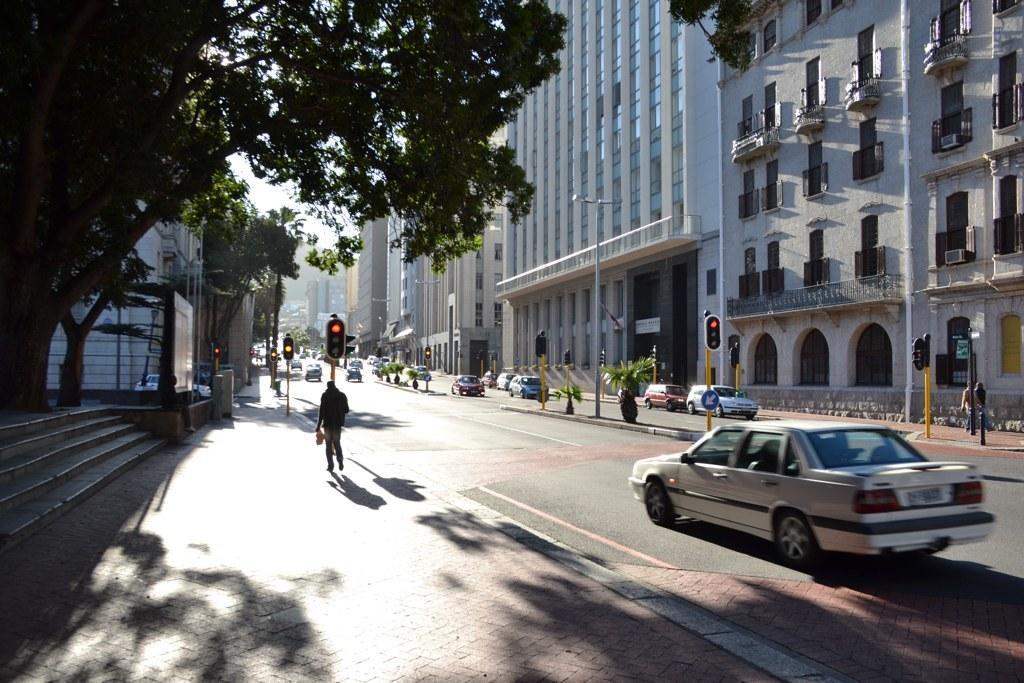Describe this image in one or two sentences. In this image I can see the road, few vehicles on the road, the sidewalk, few persons standing on the sidewalk, few traffic signals, few stairs, few trees which are green in color and few buildings on both sides of the road. In the background I can see the sky. 